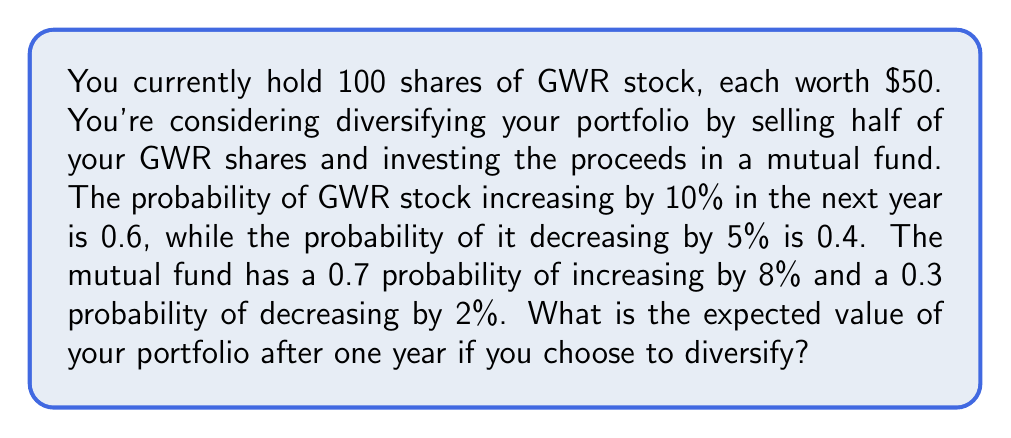Show me your answer to this math problem. Let's approach this step-by-step:

1. Current portfolio value:
   100 shares × $50 = $5000

2. If you diversify, you'll have:
   50 shares of GWR stock (worth $2500)
   $2500 in the mutual fund

3. Expected value of GWR stock after one year:
   $$E(GWR) = 2500 \times (0.6 \times 1.10 + 0.4 \times 0.95)$$
   $$E(GWR) = 2500 \times (0.66 + 0.38) = 2500 \times 1.04 = $2600$$

4. Expected value of mutual fund after one year:
   $$E(MF) = 2500 \times (0.7 \times 1.08 + 0.3 \times 0.98)$$
   $$E(MF) = 2500 \times (0.756 + 0.294) = 2500 \times 1.05 = $2625$$

5. Total expected value of diversified portfolio:
   $$E(Total) = E(GWR) + E(MF) = $2600 + $2625 = $5225$$

Therefore, the expected value of your diversified portfolio after one year is $5225.
Answer: $5225 